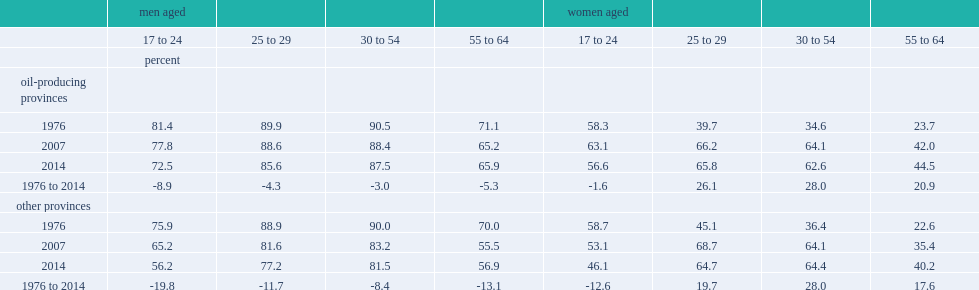In the oil-producing provinces, how many percent of the full-time employment rate of men aged 30 to 54 is declined between 1976 and 2014 compared with a decline of 8.4 percentage points in other provinces? 3. Among men aged 25 to 29, how many percent of the rate is declined in oil-producing provinces compared with 11.7 percentage points elsewhere? 4.3. Among women aged 17 to 24, how many percent of the full-time employment rate is declined in other provinces? 12.6. 